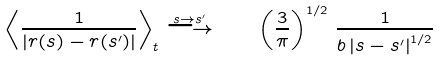Convert formula to latex. <formula><loc_0><loc_0><loc_500><loc_500>\left \langle \frac { 1 } { \left | r ( s ) - r ( s ^ { \prime } ) \right | } \right \rangle _ { t } \stackrel { s \to s ^ { \prime } } { \longrightarrow } \quad \left ( \frac { 3 } { \pi } \right ) ^ { 1 / 2 } \, \frac { 1 } { b \left | s - s ^ { \prime } \right | ^ { 1 / 2 } }</formula> 